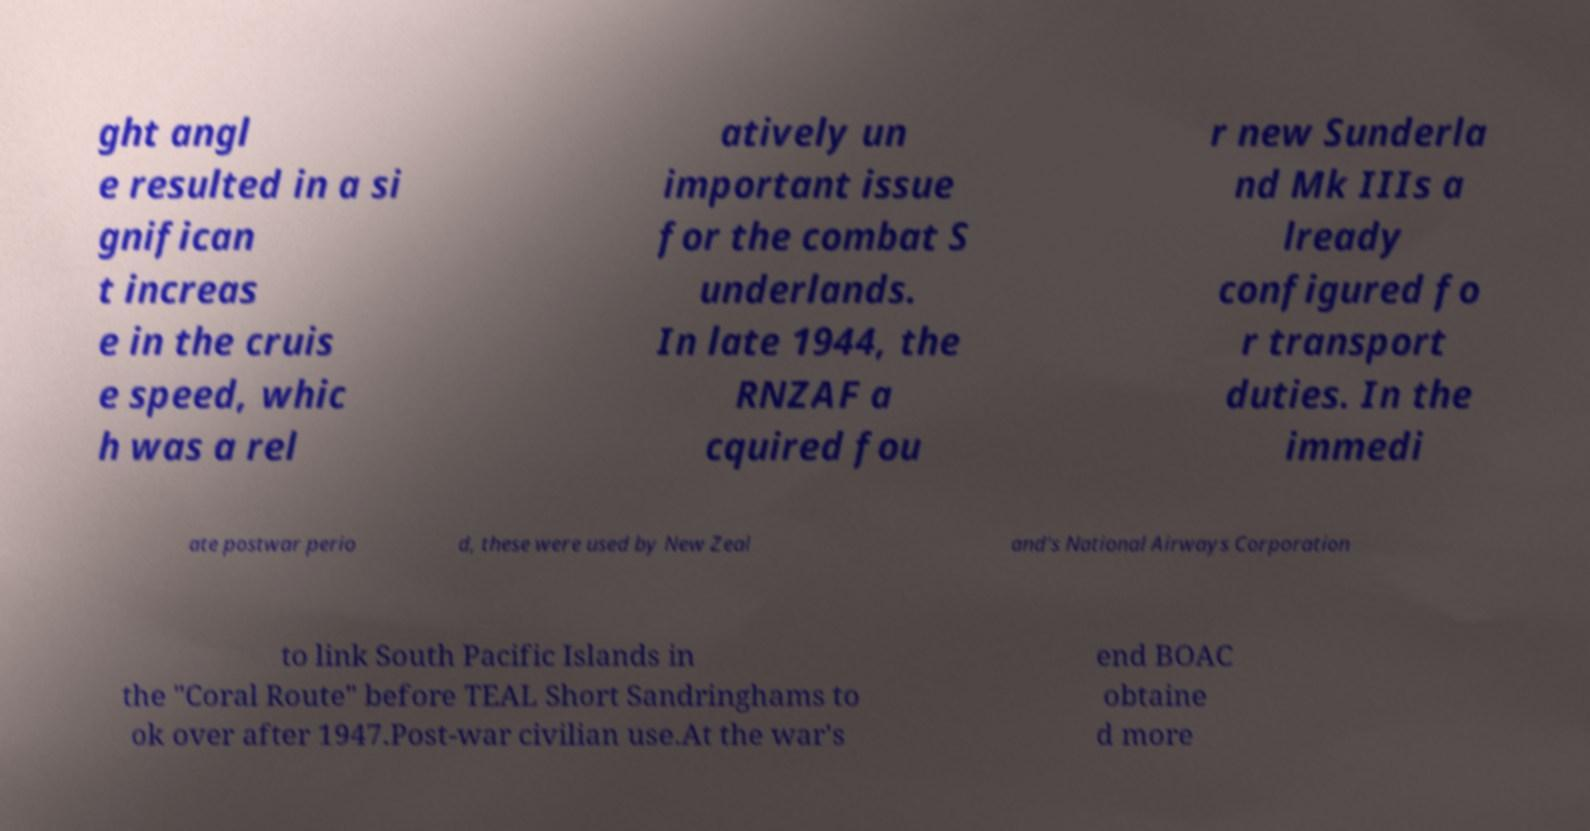Can you accurately transcribe the text from the provided image for me? ght angl e resulted in a si gnifican t increas e in the cruis e speed, whic h was a rel atively un important issue for the combat S underlands. In late 1944, the RNZAF a cquired fou r new Sunderla nd Mk IIIs a lready configured fo r transport duties. In the immedi ate postwar perio d, these were used by New Zeal and's National Airways Corporation to link South Pacific Islands in the "Coral Route" before TEAL Short Sandringhams to ok over after 1947.Post-war civilian use.At the war's end BOAC obtaine d more 